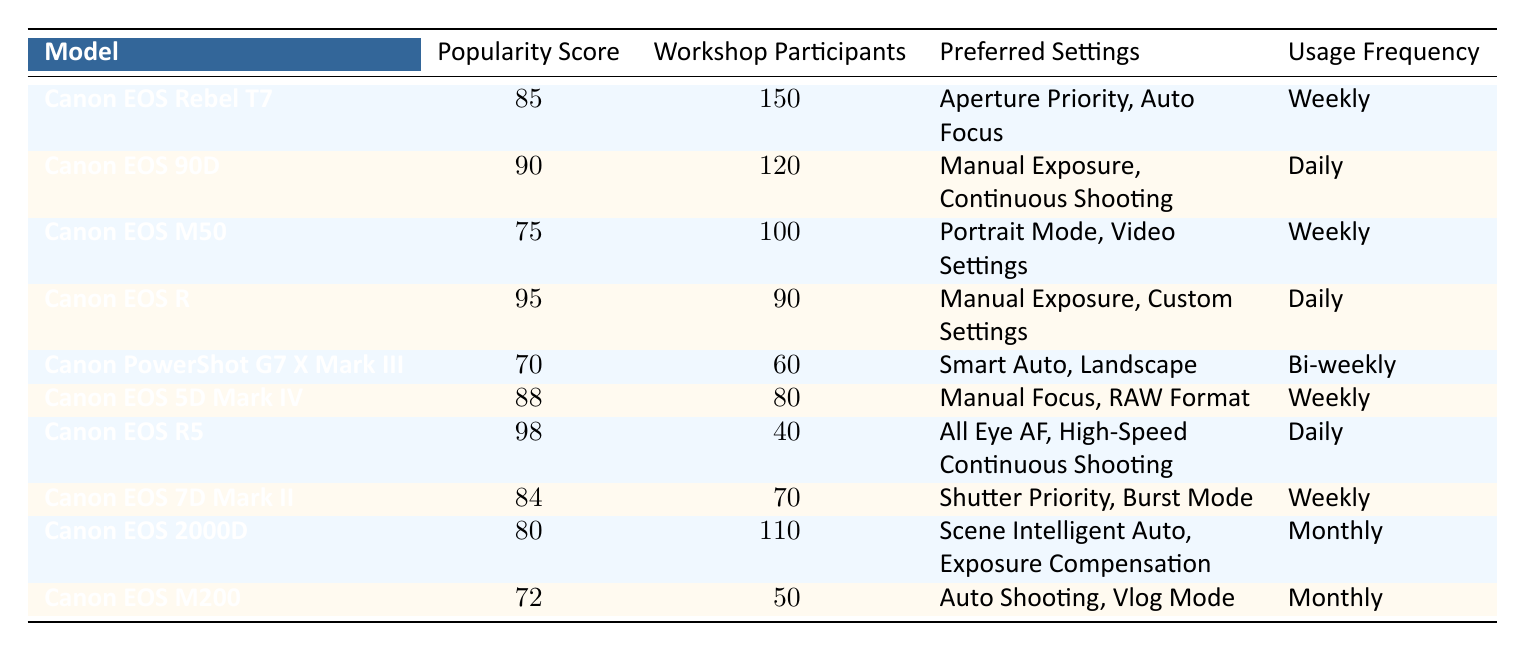What is the most popular Canon camera model based on the popularity score? The highest popularity score in the table is 98, which corresponds to the Canon EOS R5.
Answer: Canon EOS R5 How many workshop participants are associated with the Canon EOS Rebel T7? The table shows that there are 150 workshop participants for the Canon EOS Rebel T7.
Answer: 150 What is the usage frequency for the Canon EOS 90D? According to the table, the Canon EOS 90D has a usage frequency of "Daily."
Answer: Daily Which camera has the lowest popularity score? The Canon PowerShot G7 X Mark III has the lowest popularity score of 70.
Answer: Canon PowerShot G7 X Mark III What is the average popularity score of all Canon camera models listed? To find the average, sum the popularity scores (85 + 90 + 75 + 95 + 70 + 88 + 98 + 84 + 80 + 72 =  909) and divide by the number of models (10). The average is 909/10 = 90.9.
Answer: 90.9 How many cameras have a daily usage frequency? The Canon EOS 90D, Canon EOS R, and Canon EOS R5 all have a daily usage frequency, making a total of 3 cameras.
Answer: 3 Do more participants prefer Canon EOS models with a daily usage frequency than those with a bi-weekly usage frequency? The sum of workshop participants for daily usage frequency (120 + 90 + 40 = 250) is compared to bi-weekly (60). Since 250 > 60, the answer is yes.
Answer: Yes What is the total number of workshop participants for models that have a weekly usage frequency? The Canon EOS Rebel T7 (150), Canon EOS M50 (100), Canon EOS 5D Mark IV (80), and Canon EOS 7D Mark II (70) have weekly usage. Adding them up gives 150 + 100 + 80 + 70 = 400 participants.
Answer: 400 Is there any Canon camera model with a popularity score greater than 90 that has monthly usage frequency? By checking the table, no model with a popularity score greater than 90 has a monthly usage frequency. Thus, the answer is no.
Answer: No Which Canon camera model has the second highest number of workshop participants? The Canon EOS 90D has 120 participants, which is the second highest number after Canon EOS Rebel T7 (150).
Answer: Canon EOS 90D 